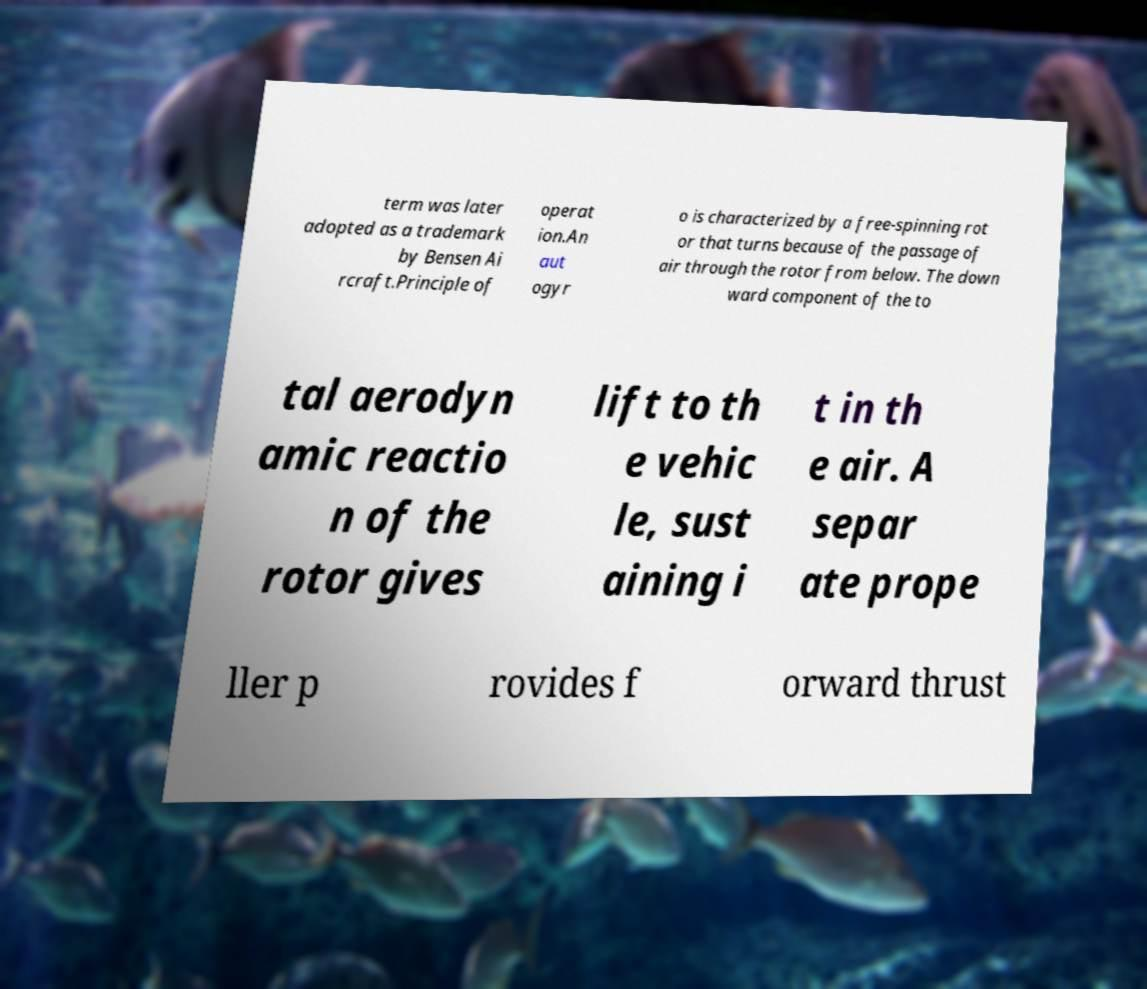Please identify and transcribe the text found in this image. term was later adopted as a trademark by Bensen Ai rcraft.Principle of operat ion.An aut ogyr o is characterized by a free-spinning rot or that turns because of the passage of air through the rotor from below. The down ward component of the to tal aerodyn amic reactio n of the rotor gives lift to th e vehic le, sust aining i t in th e air. A separ ate prope ller p rovides f orward thrust 